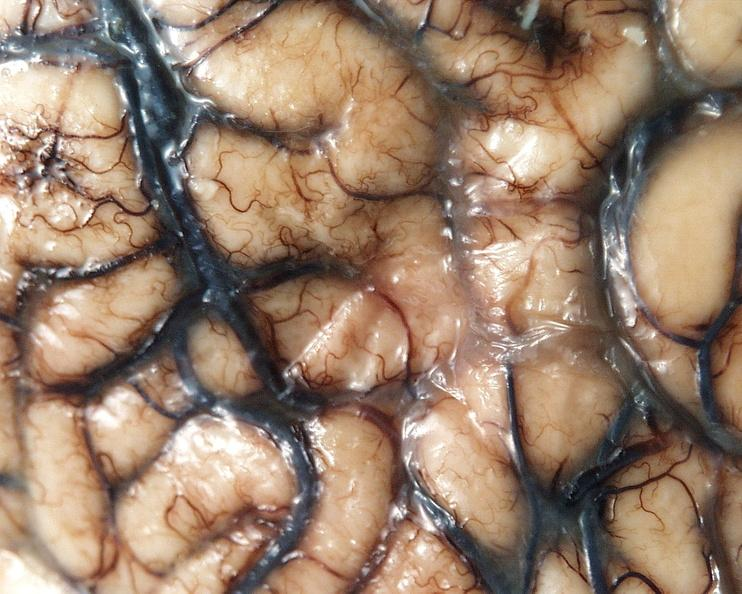does endometritis postpartum show brain, cryptococcal meningitis?
Answer the question using a single word or phrase. No 